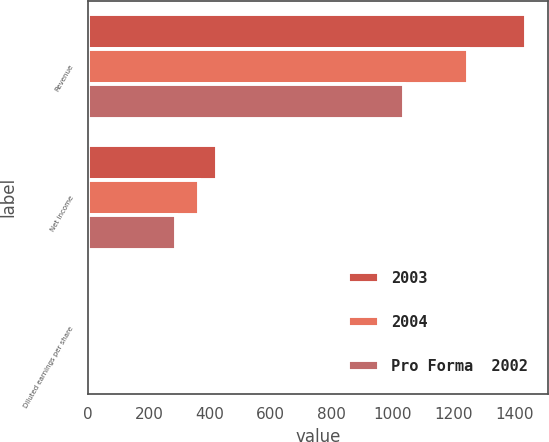Convert chart to OTSL. <chart><loc_0><loc_0><loc_500><loc_500><stacked_bar_chart><ecel><fcel>Revenue<fcel>Net income<fcel>Diluted earnings per share<nl><fcel>2003<fcel>1438.3<fcel>425.1<fcel>2.79<nl><fcel>2004<fcel>1246.6<fcel>363.9<fcel>2.39<nl><fcel>Pro Forma  2002<fcel>1038.4<fcel>288<fcel>1.83<nl></chart> 